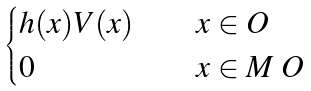<formula> <loc_0><loc_0><loc_500><loc_500>\begin{cases} h ( x ) V ( x ) \quad & x \in O \\ 0 \quad & x \in M \ O \end{cases}</formula> 